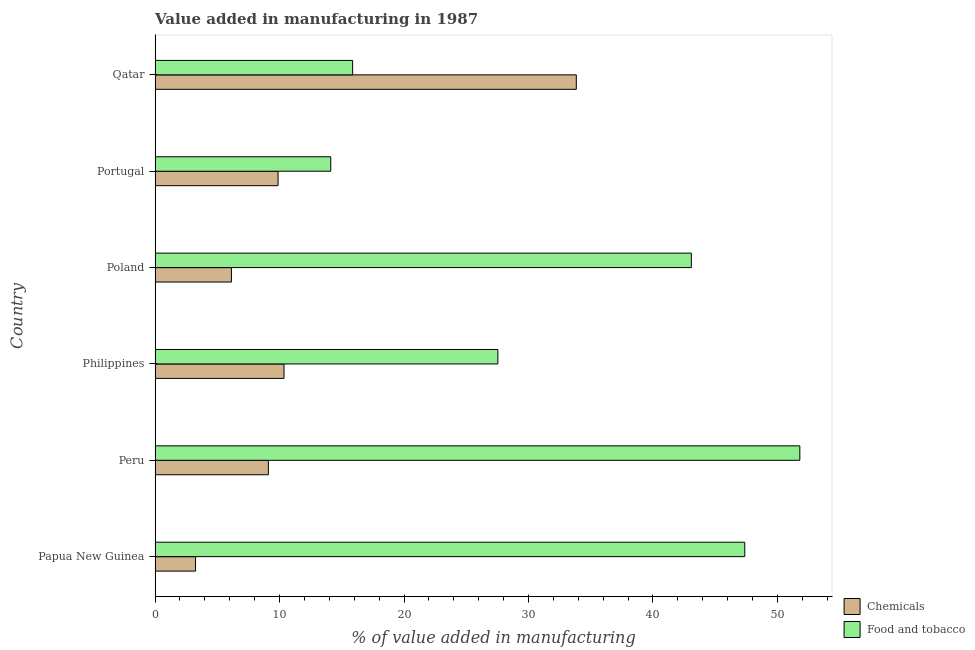Are the number of bars on each tick of the Y-axis equal?
Provide a short and direct response. Yes. How many bars are there on the 2nd tick from the top?
Keep it short and to the point. 2. What is the value added by  manufacturing chemicals in Portugal?
Offer a terse response. 9.88. Across all countries, what is the maximum value added by manufacturing food and tobacco?
Offer a terse response. 51.8. Across all countries, what is the minimum value added by  manufacturing chemicals?
Your response must be concise. 3.25. In which country was the value added by  manufacturing chemicals maximum?
Your answer should be compact. Qatar. In which country was the value added by  manufacturing chemicals minimum?
Keep it short and to the point. Papua New Guinea. What is the total value added by  manufacturing chemicals in the graph?
Keep it short and to the point. 72.57. What is the difference between the value added by  manufacturing chemicals in Peru and that in Qatar?
Offer a terse response. -24.74. What is the difference between the value added by  manufacturing chemicals in Philippines and the value added by manufacturing food and tobacco in Qatar?
Provide a succinct answer. -5.51. What is the average value added by  manufacturing chemicals per country?
Offer a terse response. 12.1. What is the difference between the value added by  manufacturing chemicals and value added by manufacturing food and tobacco in Qatar?
Your response must be concise. 17.97. In how many countries, is the value added by  manufacturing chemicals greater than 14 %?
Provide a short and direct response. 1. What is the ratio of the value added by manufacturing food and tobacco in Papua New Guinea to that in Philippines?
Keep it short and to the point. 1.72. What is the difference between the highest and the second highest value added by manufacturing food and tobacco?
Offer a terse response. 4.42. What is the difference between the highest and the lowest value added by  manufacturing chemicals?
Make the answer very short. 30.59. In how many countries, is the value added by  manufacturing chemicals greater than the average value added by  manufacturing chemicals taken over all countries?
Provide a succinct answer. 1. Is the sum of the value added by manufacturing food and tobacco in Peru and Portugal greater than the maximum value added by  manufacturing chemicals across all countries?
Ensure brevity in your answer.  Yes. What does the 1st bar from the top in Peru represents?
Make the answer very short. Food and tobacco. What does the 2nd bar from the bottom in Qatar represents?
Provide a short and direct response. Food and tobacco. How many bars are there?
Give a very brief answer. 12. Are all the bars in the graph horizontal?
Make the answer very short. Yes. How many countries are there in the graph?
Offer a very short reply. 6. What is the difference between two consecutive major ticks on the X-axis?
Offer a very short reply. 10. Where does the legend appear in the graph?
Ensure brevity in your answer.  Bottom right. How many legend labels are there?
Your response must be concise. 2. What is the title of the graph?
Give a very brief answer. Value added in manufacturing in 1987. Does "Personal remittances" appear as one of the legend labels in the graph?
Keep it short and to the point. No. What is the label or title of the X-axis?
Keep it short and to the point. % of value added in manufacturing. What is the % of value added in manufacturing in Chemicals in Papua New Guinea?
Give a very brief answer. 3.25. What is the % of value added in manufacturing of Food and tobacco in Papua New Guinea?
Offer a very short reply. 47.37. What is the % of value added in manufacturing in Chemicals in Peru?
Give a very brief answer. 9.1. What is the % of value added in manufacturing in Food and tobacco in Peru?
Make the answer very short. 51.8. What is the % of value added in manufacturing of Chemicals in Philippines?
Your answer should be compact. 10.36. What is the % of value added in manufacturing in Food and tobacco in Philippines?
Provide a short and direct response. 27.54. What is the % of value added in manufacturing of Chemicals in Poland?
Your answer should be compact. 6.13. What is the % of value added in manufacturing of Food and tobacco in Poland?
Ensure brevity in your answer.  43.08. What is the % of value added in manufacturing of Chemicals in Portugal?
Provide a succinct answer. 9.88. What is the % of value added in manufacturing of Food and tobacco in Portugal?
Offer a very short reply. 14.11. What is the % of value added in manufacturing in Chemicals in Qatar?
Your answer should be compact. 33.84. What is the % of value added in manufacturing in Food and tobacco in Qatar?
Ensure brevity in your answer.  15.87. Across all countries, what is the maximum % of value added in manufacturing in Chemicals?
Provide a short and direct response. 33.84. Across all countries, what is the maximum % of value added in manufacturing of Food and tobacco?
Provide a succinct answer. 51.8. Across all countries, what is the minimum % of value added in manufacturing of Chemicals?
Offer a very short reply. 3.25. Across all countries, what is the minimum % of value added in manufacturing of Food and tobacco?
Keep it short and to the point. 14.11. What is the total % of value added in manufacturing in Chemicals in the graph?
Give a very brief answer. 72.57. What is the total % of value added in manufacturing in Food and tobacco in the graph?
Offer a very short reply. 199.78. What is the difference between the % of value added in manufacturing in Chemicals in Papua New Guinea and that in Peru?
Offer a terse response. -5.85. What is the difference between the % of value added in manufacturing of Food and tobacco in Papua New Guinea and that in Peru?
Your answer should be compact. -4.42. What is the difference between the % of value added in manufacturing in Chemicals in Papua New Guinea and that in Philippines?
Your answer should be very brief. -7.11. What is the difference between the % of value added in manufacturing in Food and tobacco in Papua New Guinea and that in Philippines?
Provide a succinct answer. 19.83. What is the difference between the % of value added in manufacturing of Chemicals in Papua New Guinea and that in Poland?
Provide a short and direct response. -2.88. What is the difference between the % of value added in manufacturing of Food and tobacco in Papua New Guinea and that in Poland?
Offer a very short reply. 4.29. What is the difference between the % of value added in manufacturing of Chemicals in Papua New Guinea and that in Portugal?
Give a very brief answer. -6.63. What is the difference between the % of value added in manufacturing of Food and tobacco in Papua New Guinea and that in Portugal?
Your response must be concise. 33.26. What is the difference between the % of value added in manufacturing of Chemicals in Papua New Guinea and that in Qatar?
Provide a short and direct response. -30.59. What is the difference between the % of value added in manufacturing of Food and tobacco in Papua New Guinea and that in Qatar?
Offer a terse response. 31.5. What is the difference between the % of value added in manufacturing of Chemicals in Peru and that in Philippines?
Your response must be concise. -1.25. What is the difference between the % of value added in manufacturing of Food and tobacco in Peru and that in Philippines?
Offer a very short reply. 24.26. What is the difference between the % of value added in manufacturing in Chemicals in Peru and that in Poland?
Provide a succinct answer. 2.97. What is the difference between the % of value added in manufacturing in Food and tobacco in Peru and that in Poland?
Your answer should be very brief. 8.72. What is the difference between the % of value added in manufacturing of Chemicals in Peru and that in Portugal?
Offer a very short reply. -0.78. What is the difference between the % of value added in manufacturing in Food and tobacco in Peru and that in Portugal?
Offer a very short reply. 37.69. What is the difference between the % of value added in manufacturing of Chemicals in Peru and that in Qatar?
Your answer should be very brief. -24.74. What is the difference between the % of value added in manufacturing in Food and tobacco in Peru and that in Qatar?
Provide a succinct answer. 35.92. What is the difference between the % of value added in manufacturing in Chemicals in Philippines and that in Poland?
Your response must be concise. 4.22. What is the difference between the % of value added in manufacturing in Food and tobacco in Philippines and that in Poland?
Make the answer very short. -15.54. What is the difference between the % of value added in manufacturing in Chemicals in Philippines and that in Portugal?
Your answer should be very brief. 0.48. What is the difference between the % of value added in manufacturing of Food and tobacco in Philippines and that in Portugal?
Offer a terse response. 13.43. What is the difference between the % of value added in manufacturing of Chemicals in Philippines and that in Qatar?
Offer a very short reply. -23.48. What is the difference between the % of value added in manufacturing in Food and tobacco in Philippines and that in Qatar?
Your response must be concise. 11.67. What is the difference between the % of value added in manufacturing in Chemicals in Poland and that in Portugal?
Your response must be concise. -3.75. What is the difference between the % of value added in manufacturing of Food and tobacco in Poland and that in Portugal?
Offer a terse response. 28.97. What is the difference between the % of value added in manufacturing in Chemicals in Poland and that in Qatar?
Make the answer very short. -27.71. What is the difference between the % of value added in manufacturing in Food and tobacco in Poland and that in Qatar?
Your answer should be compact. 27.21. What is the difference between the % of value added in manufacturing in Chemicals in Portugal and that in Qatar?
Ensure brevity in your answer.  -23.96. What is the difference between the % of value added in manufacturing of Food and tobacco in Portugal and that in Qatar?
Make the answer very short. -1.76. What is the difference between the % of value added in manufacturing in Chemicals in Papua New Guinea and the % of value added in manufacturing in Food and tobacco in Peru?
Provide a short and direct response. -48.55. What is the difference between the % of value added in manufacturing in Chemicals in Papua New Guinea and the % of value added in manufacturing in Food and tobacco in Philippines?
Your answer should be compact. -24.29. What is the difference between the % of value added in manufacturing of Chemicals in Papua New Guinea and the % of value added in manufacturing of Food and tobacco in Poland?
Your response must be concise. -39.83. What is the difference between the % of value added in manufacturing of Chemicals in Papua New Guinea and the % of value added in manufacturing of Food and tobacco in Portugal?
Provide a short and direct response. -10.86. What is the difference between the % of value added in manufacturing of Chemicals in Papua New Guinea and the % of value added in manufacturing of Food and tobacco in Qatar?
Your answer should be compact. -12.62. What is the difference between the % of value added in manufacturing of Chemicals in Peru and the % of value added in manufacturing of Food and tobacco in Philippines?
Your response must be concise. -18.44. What is the difference between the % of value added in manufacturing in Chemicals in Peru and the % of value added in manufacturing in Food and tobacco in Poland?
Offer a terse response. -33.98. What is the difference between the % of value added in manufacturing in Chemicals in Peru and the % of value added in manufacturing in Food and tobacco in Portugal?
Your answer should be compact. -5.01. What is the difference between the % of value added in manufacturing in Chemicals in Peru and the % of value added in manufacturing in Food and tobacco in Qatar?
Your answer should be compact. -6.77. What is the difference between the % of value added in manufacturing of Chemicals in Philippines and the % of value added in manufacturing of Food and tobacco in Poland?
Offer a terse response. -32.72. What is the difference between the % of value added in manufacturing of Chemicals in Philippines and the % of value added in manufacturing of Food and tobacco in Portugal?
Ensure brevity in your answer.  -3.75. What is the difference between the % of value added in manufacturing of Chemicals in Philippines and the % of value added in manufacturing of Food and tobacco in Qatar?
Your answer should be compact. -5.51. What is the difference between the % of value added in manufacturing in Chemicals in Poland and the % of value added in manufacturing in Food and tobacco in Portugal?
Ensure brevity in your answer.  -7.98. What is the difference between the % of value added in manufacturing in Chemicals in Poland and the % of value added in manufacturing in Food and tobacco in Qatar?
Ensure brevity in your answer.  -9.74. What is the difference between the % of value added in manufacturing of Chemicals in Portugal and the % of value added in manufacturing of Food and tobacco in Qatar?
Your answer should be compact. -5.99. What is the average % of value added in manufacturing of Chemicals per country?
Provide a short and direct response. 12.1. What is the average % of value added in manufacturing of Food and tobacco per country?
Provide a succinct answer. 33.3. What is the difference between the % of value added in manufacturing of Chemicals and % of value added in manufacturing of Food and tobacco in Papua New Guinea?
Provide a short and direct response. -44.12. What is the difference between the % of value added in manufacturing in Chemicals and % of value added in manufacturing in Food and tobacco in Peru?
Give a very brief answer. -42.69. What is the difference between the % of value added in manufacturing in Chemicals and % of value added in manufacturing in Food and tobacco in Philippines?
Your answer should be compact. -17.18. What is the difference between the % of value added in manufacturing of Chemicals and % of value added in manufacturing of Food and tobacco in Poland?
Offer a very short reply. -36.95. What is the difference between the % of value added in manufacturing of Chemicals and % of value added in manufacturing of Food and tobacco in Portugal?
Your answer should be compact. -4.23. What is the difference between the % of value added in manufacturing in Chemicals and % of value added in manufacturing in Food and tobacco in Qatar?
Provide a short and direct response. 17.97. What is the ratio of the % of value added in manufacturing of Chemicals in Papua New Guinea to that in Peru?
Provide a short and direct response. 0.36. What is the ratio of the % of value added in manufacturing of Food and tobacco in Papua New Guinea to that in Peru?
Offer a very short reply. 0.91. What is the ratio of the % of value added in manufacturing in Chemicals in Papua New Guinea to that in Philippines?
Provide a succinct answer. 0.31. What is the ratio of the % of value added in manufacturing of Food and tobacco in Papua New Guinea to that in Philippines?
Provide a succinct answer. 1.72. What is the ratio of the % of value added in manufacturing of Chemicals in Papua New Guinea to that in Poland?
Offer a terse response. 0.53. What is the ratio of the % of value added in manufacturing of Food and tobacco in Papua New Guinea to that in Poland?
Give a very brief answer. 1.1. What is the ratio of the % of value added in manufacturing of Chemicals in Papua New Guinea to that in Portugal?
Offer a very short reply. 0.33. What is the ratio of the % of value added in manufacturing in Food and tobacco in Papua New Guinea to that in Portugal?
Your answer should be compact. 3.36. What is the ratio of the % of value added in manufacturing in Chemicals in Papua New Guinea to that in Qatar?
Make the answer very short. 0.1. What is the ratio of the % of value added in manufacturing in Food and tobacco in Papua New Guinea to that in Qatar?
Give a very brief answer. 2.98. What is the ratio of the % of value added in manufacturing in Chemicals in Peru to that in Philippines?
Give a very brief answer. 0.88. What is the ratio of the % of value added in manufacturing of Food and tobacco in Peru to that in Philippines?
Provide a succinct answer. 1.88. What is the ratio of the % of value added in manufacturing in Chemicals in Peru to that in Poland?
Provide a succinct answer. 1.48. What is the ratio of the % of value added in manufacturing of Food and tobacco in Peru to that in Poland?
Offer a very short reply. 1.2. What is the ratio of the % of value added in manufacturing in Chemicals in Peru to that in Portugal?
Your answer should be compact. 0.92. What is the ratio of the % of value added in manufacturing of Food and tobacco in Peru to that in Portugal?
Ensure brevity in your answer.  3.67. What is the ratio of the % of value added in manufacturing in Chemicals in Peru to that in Qatar?
Offer a very short reply. 0.27. What is the ratio of the % of value added in manufacturing of Food and tobacco in Peru to that in Qatar?
Your response must be concise. 3.26. What is the ratio of the % of value added in manufacturing of Chemicals in Philippines to that in Poland?
Keep it short and to the point. 1.69. What is the ratio of the % of value added in manufacturing in Food and tobacco in Philippines to that in Poland?
Provide a succinct answer. 0.64. What is the ratio of the % of value added in manufacturing of Chemicals in Philippines to that in Portugal?
Make the answer very short. 1.05. What is the ratio of the % of value added in manufacturing of Food and tobacco in Philippines to that in Portugal?
Make the answer very short. 1.95. What is the ratio of the % of value added in manufacturing in Chemicals in Philippines to that in Qatar?
Keep it short and to the point. 0.31. What is the ratio of the % of value added in manufacturing of Food and tobacco in Philippines to that in Qatar?
Your answer should be compact. 1.74. What is the ratio of the % of value added in manufacturing in Chemicals in Poland to that in Portugal?
Your answer should be compact. 0.62. What is the ratio of the % of value added in manufacturing in Food and tobacco in Poland to that in Portugal?
Your answer should be compact. 3.05. What is the ratio of the % of value added in manufacturing in Chemicals in Poland to that in Qatar?
Provide a short and direct response. 0.18. What is the ratio of the % of value added in manufacturing in Food and tobacco in Poland to that in Qatar?
Your response must be concise. 2.71. What is the ratio of the % of value added in manufacturing in Chemicals in Portugal to that in Qatar?
Keep it short and to the point. 0.29. What is the ratio of the % of value added in manufacturing in Food and tobacco in Portugal to that in Qatar?
Keep it short and to the point. 0.89. What is the difference between the highest and the second highest % of value added in manufacturing of Chemicals?
Offer a very short reply. 23.48. What is the difference between the highest and the second highest % of value added in manufacturing in Food and tobacco?
Make the answer very short. 4.42. What is the difference between the highest and the lowest % of value added in manufacturing of Chemicals?
Your answer should be very brief. 30.59. What is the difference between the highest and the lowest % of value added in manufacturing in Food and tobacco?
Give a very brief answer. 37.69. 